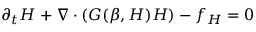Convert formula to latex. <formula><loc_0><loc_0><loc_500><loc_500>\partial _ { t } H + \nabla \cdot ( G ( \beta , H ) H ) - f _ { H } = 0</formula> 